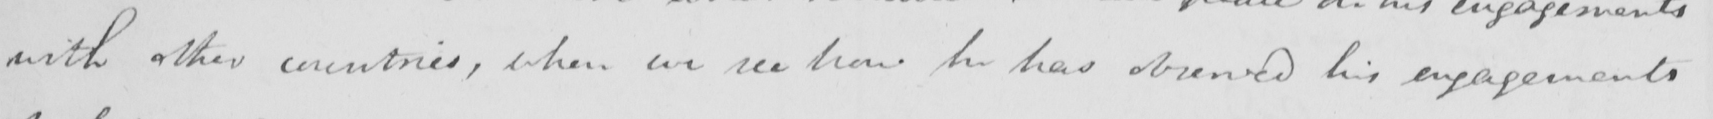Can you tell me what this handwritten text says? with other countries , when we see how he has observed his engagements 